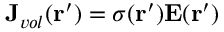<formula> <loc_0><loc_0><loc_500><loc_500>J _ { v o l } ( r ^ { \prime } ) = \sigma ( r ^ { \prime } ) E ( r ^ { \prime } )</formula> 